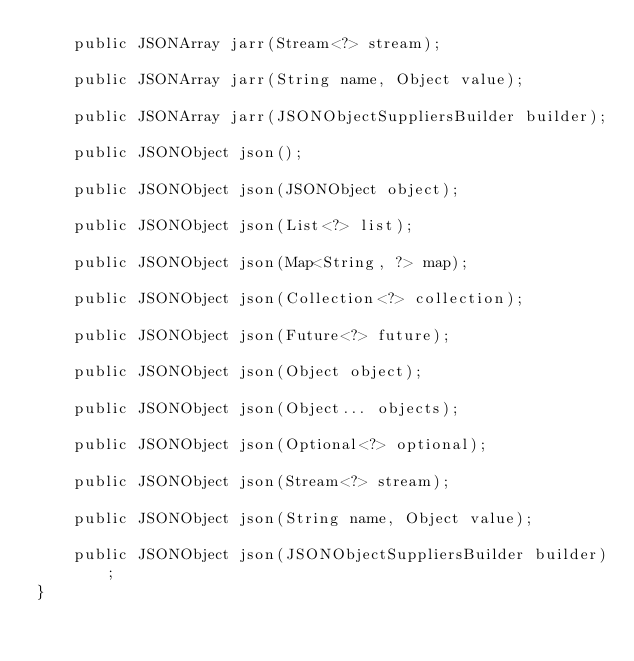<code> <loc_0><loc_0><loc_500><loc_500><_Java_>    public JSONArray jarr(Stream<?> stream);

    public JSONArray jarr(String name, Object value);

    public JSONArray jarr(JSONObjectSuppliersBuilder builder);

    public JSONObject json();

    public JSONObject json(JSONObject object);

    public JSONObject json(List<?> list);

    public JSONObject json(Map<String, ?> map);

    public JSONObject json(Collection<?> collection);

    public JSONObject json(Future<?> future);

    public JSONObject json(Object object);

    public JSONObject json(Object... objects);

    public JSONObject json(Optional<?> optional);

    public JSONObject json(Stream<?> stream);

    public JSONObject json(String name, Object value);

    public JSONObject json(JSONObjectSuppliersBuilder builder);
}</code> 